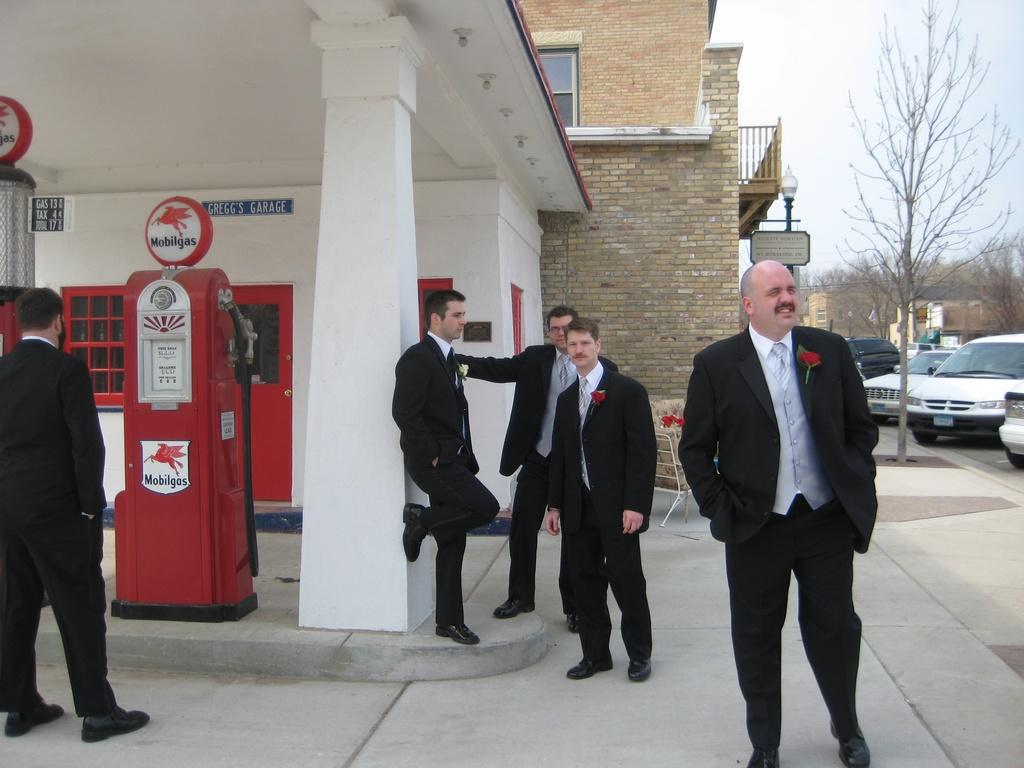What is happening on the floor in the image? There are persons standing on the floor in the image. What type of vehicles can be seen in the image? Motor vehicles are present in the image. What structures are visible in the image? Street poles, street lights, information boards, buildings, and name boards are visible in the image. What type of vegetation is present in the image? Trees are present in the image. What type of lighting is visible in the image? Electric lights are visible in the image. What part of the natural environment is visible in the image? The sky is visible in the image. What type of fruit is being served on the ground in the image? There is no fruit present on the ground in the image. Can you see a turkey walking around in the image? There is no turkey present in the image. 